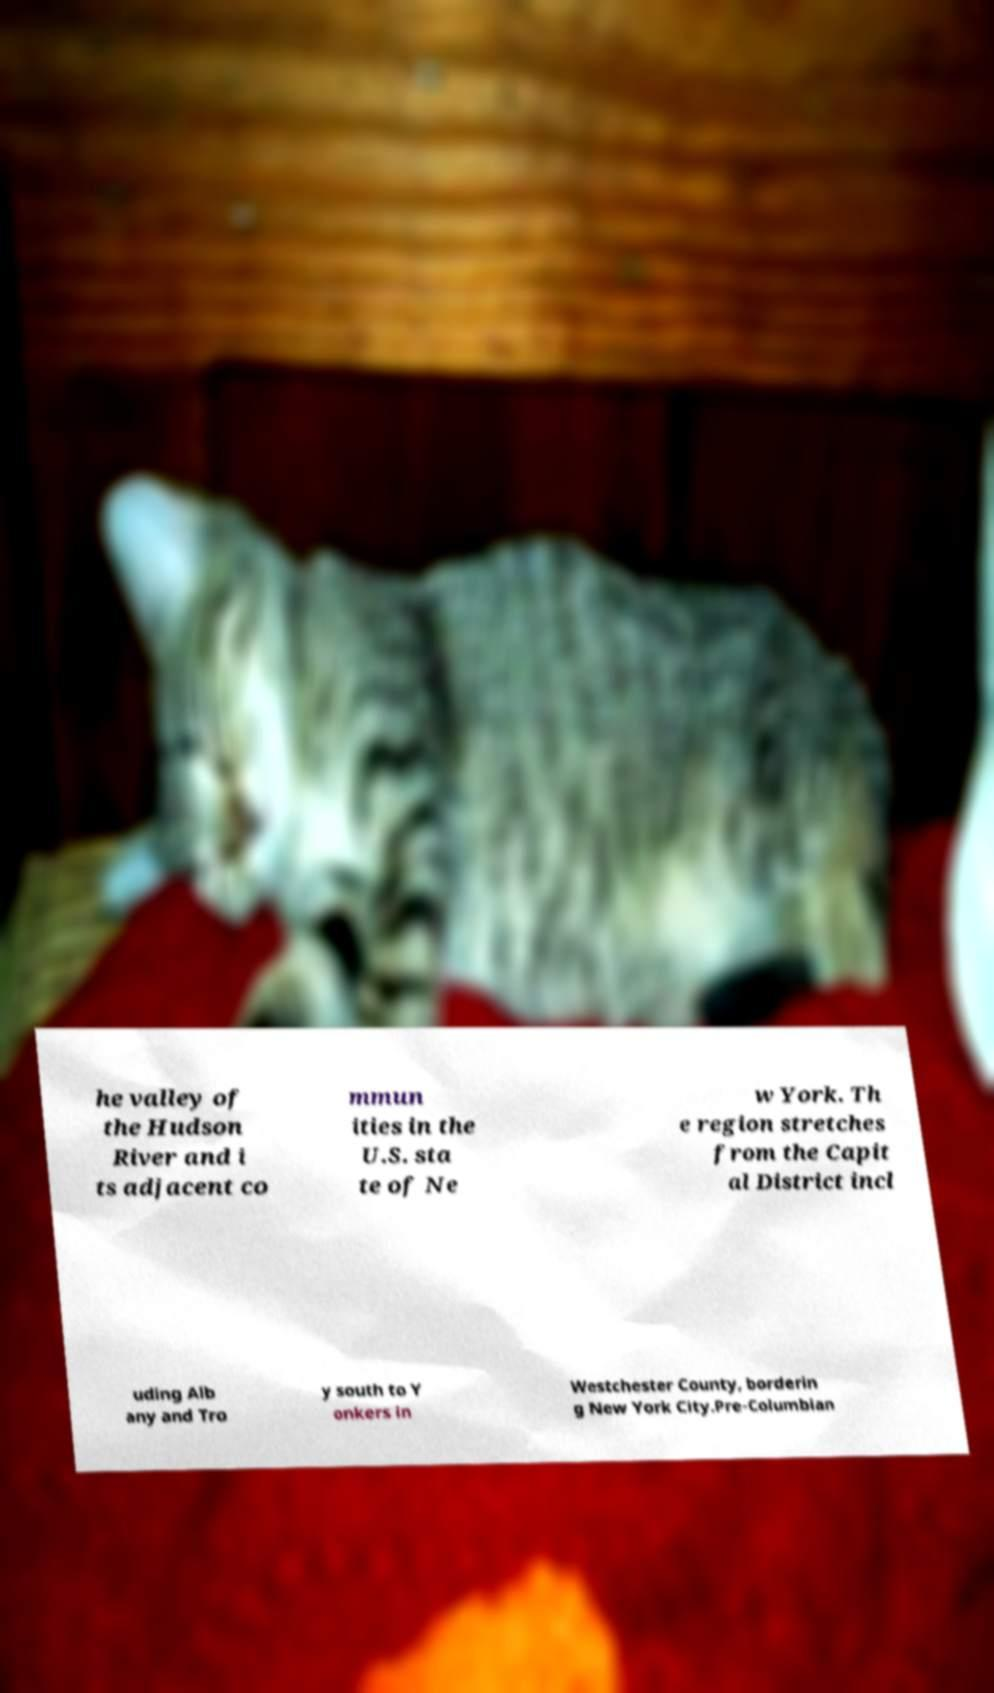There's text embedded in this image that I need extracted. Can you transcribe it verbatim? he valley of the Hudson River and i ts adjacent co mmun ities in the U.S. sta te of Ne w York. Th e region stretches from the Capit al District incl uding Alb any and Tro y south to Y onkers in Westchester County, borderin g New York City.Pre-Columbian 